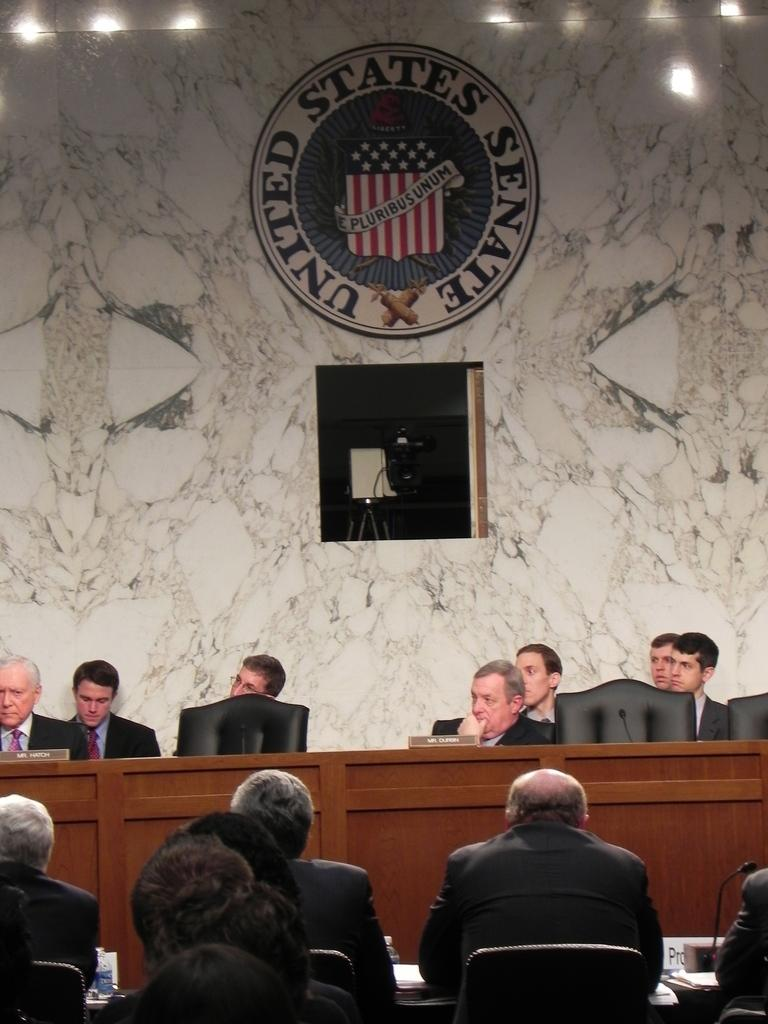What is happening in the image? There is a group of people sitting in the image. What can be observed about the people in the background? The people in the background are wearing black color blazers. What is the color of the wall in the image? The wall is in cream color. How much does the fireman weigh in the image? There is no fireman present in the image, so it is not possible to determine their weight. 